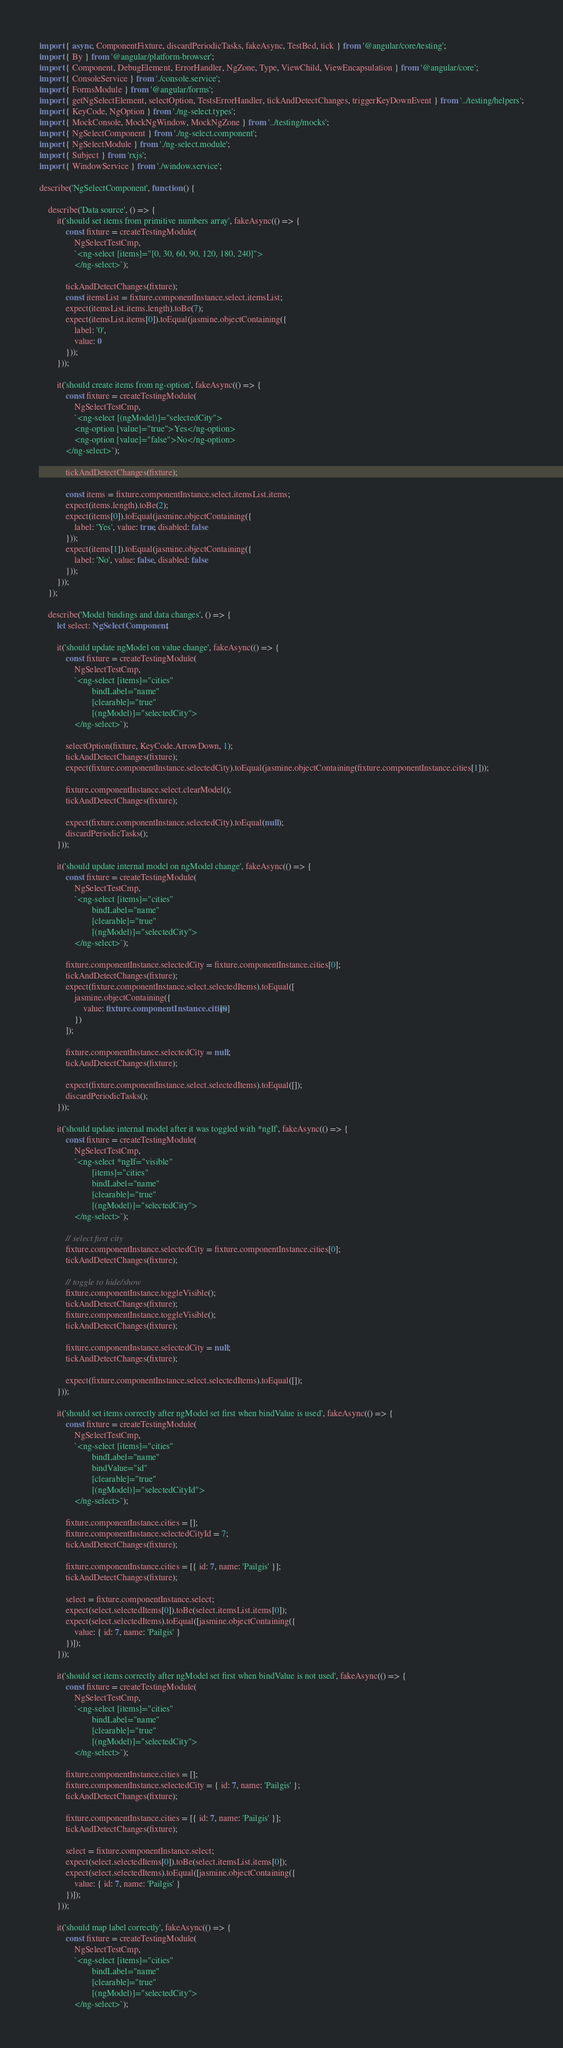<code> <loc_0><loc_0><loc_500><loc_500><_TypeScript_>import { async, ComponentFixture, discardPeriodicTasks, fakeAsync, TestBed, tick } from '@angular/core/testing';
import { By } from '@angular/platform-browser';
import { Component, DebugElement, ErrorHandler, NgZone, Type, ViewChild, ViewEncapsulation } from '@angular/core';
import { ConsoleService } from './console.service';
import { FormsModule } from '@angular/forms';
import { getNgSelectElement, selectOption, TestsErrorHandler, tickAndDetectChanges, triggerKeyDownEvent } from '../testing/helpers';
import { KeyCode, NgOption } from './ng-select.types';
import { MockConsole, MockNgWindow, MockNgZone } from '../testing/mocks';
import { NgSelectComponent } from './ng-select.component';
import { NgSelectModule } from './ng-select.module';
import { Subject } from 'rxjs';
import { WindowService } from './window.service';

describe('NgSelectComponent', function () {

    describe('Data source', () => {
        it('should set items from primitive numbers array', fakeAsync(() => {
            const fixture = createTestingModule(
                NgSelectTestCmp,
                `<ng-select [items]="[0, 30, 60, 90, 120, 180, 240]">
                </ng-select>`);

            tickAndDetectChanges(fixture);
            const itemsList = fixture.componentInstance.select.itemsList;
            expect(itemsList.items.length).toBe(7);
            expect(itemsList.items[0]).toEqual(jasmine.objectContaining({
                label: '0',
                value: 0
            }));
        }));

        it('should create items from ng-option', fakeAsync(() => {
            const fixture = createTestingModule(
                NgSelectTestCmp,
                `<ng-select [(ngModel)]="selectedCity">
                <ng-option [value]="true">Yes</ng-option>
                <ng-option [value]="false">No</ng-option>
            </ng-select>`);

            tickAndDetectChanges(fixture);

            const items = fixture.componentInstance.select.itemsList.items;
            expect(items.length).toBe(2);
            expect(items[0]).toEqual(jasmine.objectContaining({
                label: 'Yes', value: true, disabled: false
            }));
            expect(items[1]).toEqual(jasmine.objectContaining({
                label: 'No', value: false, disabled: false
            }));
        }));
    });

    describe('Model bindings and data changes', () => {
        let select: NgSelectComponent;

        it('should update ngModel on value change', fakeAsync(() => {
            const fixture = createTestingModule(
                NgSelectTestCmp,
                `<ng-select [items]="cities"
                        bindLabel="name"
                        [clearable]="true"
                        [(ngModel)]="selectedCity">
                </ng-select>`);

            selectOption(fixture, KeyCode.ArrowDown, 1);
            tickAndDetectChanges(fixture);
            expect(fixture.componentInstance.selectedCity).toEqual(jasmine.objectContaining(fixture.componentInstance.cities[1]));

            fixture.componentInstance.select.clearModel();
            tickAndDetectChanges(fixture);

            expect(fixture.componentInstance.selectedCity).toEqual(null);
            discardPeriodicTasks();
        }));

        it('should update internal model on ngModel change', fakeAsync(() => {
            const fixture = createTestingModule(
                NgSelectTestCmp,
                `<ng-select [items]="cities"
                        bindLabel="name"
                        [clearable]="true"
                        [(ngModel)]="selectedCity">
                </ng-select>`);

            fixture.componentInstance.selectedCity = fixture.componentInstance.cities[0];
            tickAndDetectChanges(fixture);
            expect(fixture.componentInstance.select.selectedItems).toEqual([
                jasmine.objectContaining({
                    value: fixture.componentInstance.cities[0]
                })
            ]);

            fixture.componentInstance.selectedCity = null;
            tickAndDetectChanges(fixture);

            expect(fixture.componentInstance.select.selectedItems).toEqual([]);
            discardPeriodicTasks();
        }));

        it('should update internal model after it was toggled with *ngIf', fakeAsync(() => {
            const fixture = createTestingModule(
                NgSelectTestCmp,
                `<ng-select *ngIf="visible"
                        [items]="cities"
                        bindLabel="name"
                        [clearable]="true"
                        [(ngModel)]="selectedCity">
                </ng-select>`);

            // select first city
            fixture.componentInstance.selectedCity = fixture.componentInstance.cities[0];
            tickAndDetectChanges(fixture);

            // toggle to hide/show
            fixture.componentInstance.toggleVisible();
            tickAndDetectChanges(fixture);
            fixture.componentInstance.toggleVisible();
            tickAndDetectChanges(fixture);

            fixture.componentInstance.selectedCity = null;
            tickAndDetectChanges(fixture);

            expect(fixture.componentInstance.select.selectedItems).toEqual([]);
        }));

        it('should set items correctly after ngModel set first when bindValue is used', fakeAsync(() => {
            const fixture = createTestingModule(
                NgSelectTestCmp,
                `<ng-select [items]="cities"
                        bindLabel="name"
                        bindValue="id"
                        [clearable]="true"
                        [(ngModel)]="selectedCityId">
                </ng-select>`);

            fixture.componentInstance.cities = [];
            fixture.componentInstance.selectedCityId = 7;
            tickAndDetectChanges(fixture);

            fixture.componentInstance.cities = [{ id: 7, name: 'Pailgis' }];
            tickAndDetectChanges(fixture);

            select = fixture.componentInstance.select;
            expect(select.selectedItems[0]).toBe(select.itemsList.items[0]);
            expect(select.selectedItems).toEqual([jasmine.objectContaining({
                value: { id: 7, name: 'Pailgis' }
            })]);
        }));

        it('should set items correctly after ngModel set first when bindValue is not used', fakeAsync(() => {
            const fixture = createTestingModule(
                NgSelectTestCmp,
                `<ng-select [items]="cities"
                        bindLabel="name"
                        [clearable]="true"
                        [(ngModel)]="selectedCity">
                </ng-select>`);

            fixture.componentInstance.cities = [];
            fixture.componentInstance.selectedCity = { id: 7, name: 'Pailgis' };
            tickAndDetectChanges(fixture);

            fixture.componentInstance.cities = [{ id: 7, name: 'Pailgis' }];
            tickAndDetectChanges(fixture);

            select = fixture.componentInstance.select;
            expect(select.selectedItems[0]).toBe(select.itemsList.items[0]);
            expect(select.selectedItems).toEqual([jasmine.objectContaining({
                value: { id: 7, name: 'Pailgis' }
            })]);
        }));

        it('should map label correctly', fakeAsync(() => {
            const fixture = createTestingModule(
                NgSelectTestCmp,
                `<ng-select [items]="cities"
                        bindLabel="name"
                        [clearable]="true"
                        [(ngModel)]="selectedCity">
                </ng-select>`);
</code> 